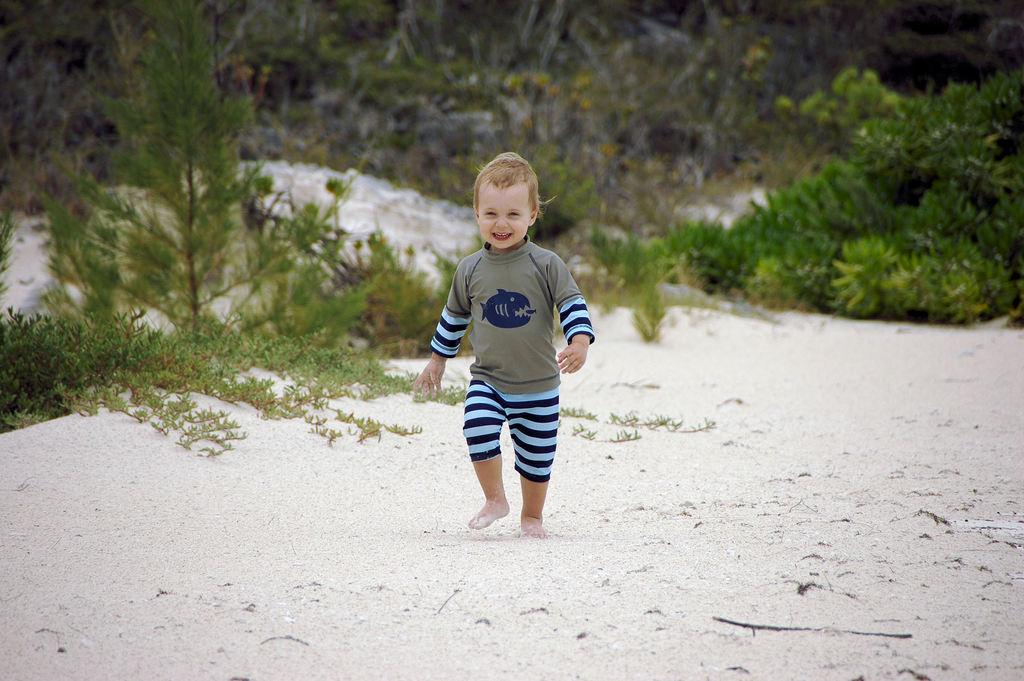Who is the main subject in the image? There is a small boy in the image. Where is the boy located in the image? The boy is in the middle of the image. What is the boy doing in the image? The boy is walking on the sand. What can be seen on the left side of the image? There is a tree on the left side of the image. What verse is the boy reciting while walking on the sand? There is no indication in the image that the boy is reciting a verse, so it cannot be determined from the picture. 